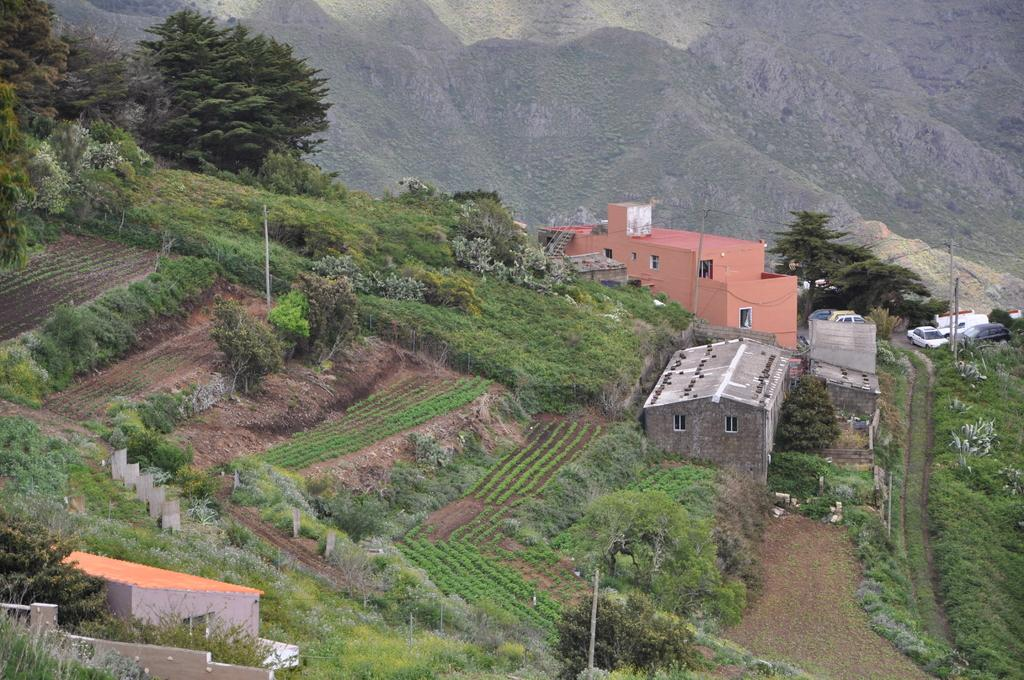What type of structures can be seen in the image? There are houses in the image. What other natural elements are present in the image? There are trees in the image. What can be seen on the right side of the image? Vehicles are parked on the road on the right side. What is visible in the background of the image? There are hills visible in the background. What type of tools does the carpenter use in the image? There is no carpenter present in the image, so it is not possible to determine what tools they might use. 